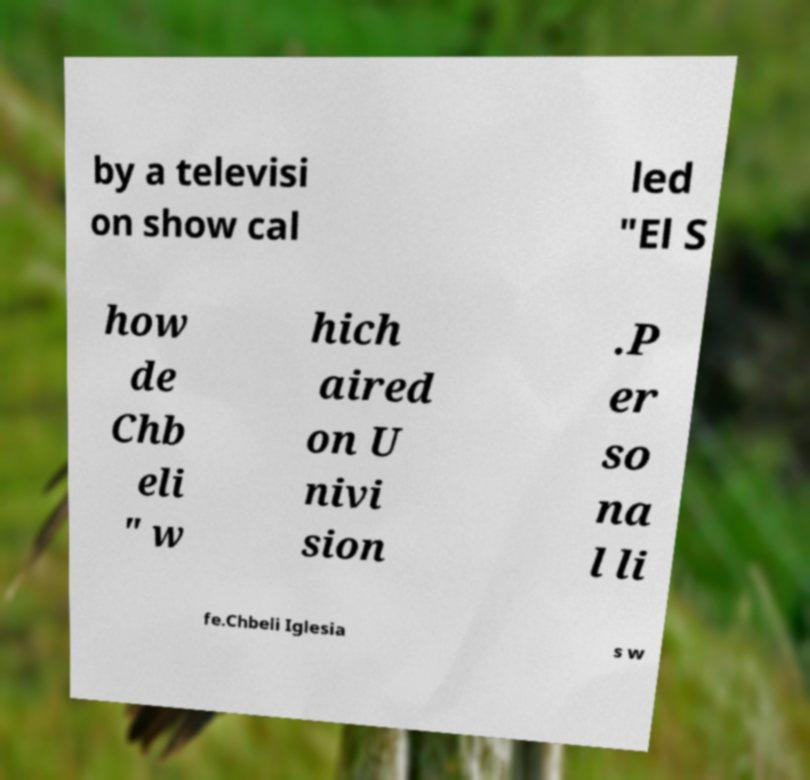Could you assist in decoding the text presented in this image and type it out clearly? by a televisi on show cal led "El S how de Chb eli " w hich aired on U nivi sion .P er so na l li fe.Chbeli Iglesia s w 